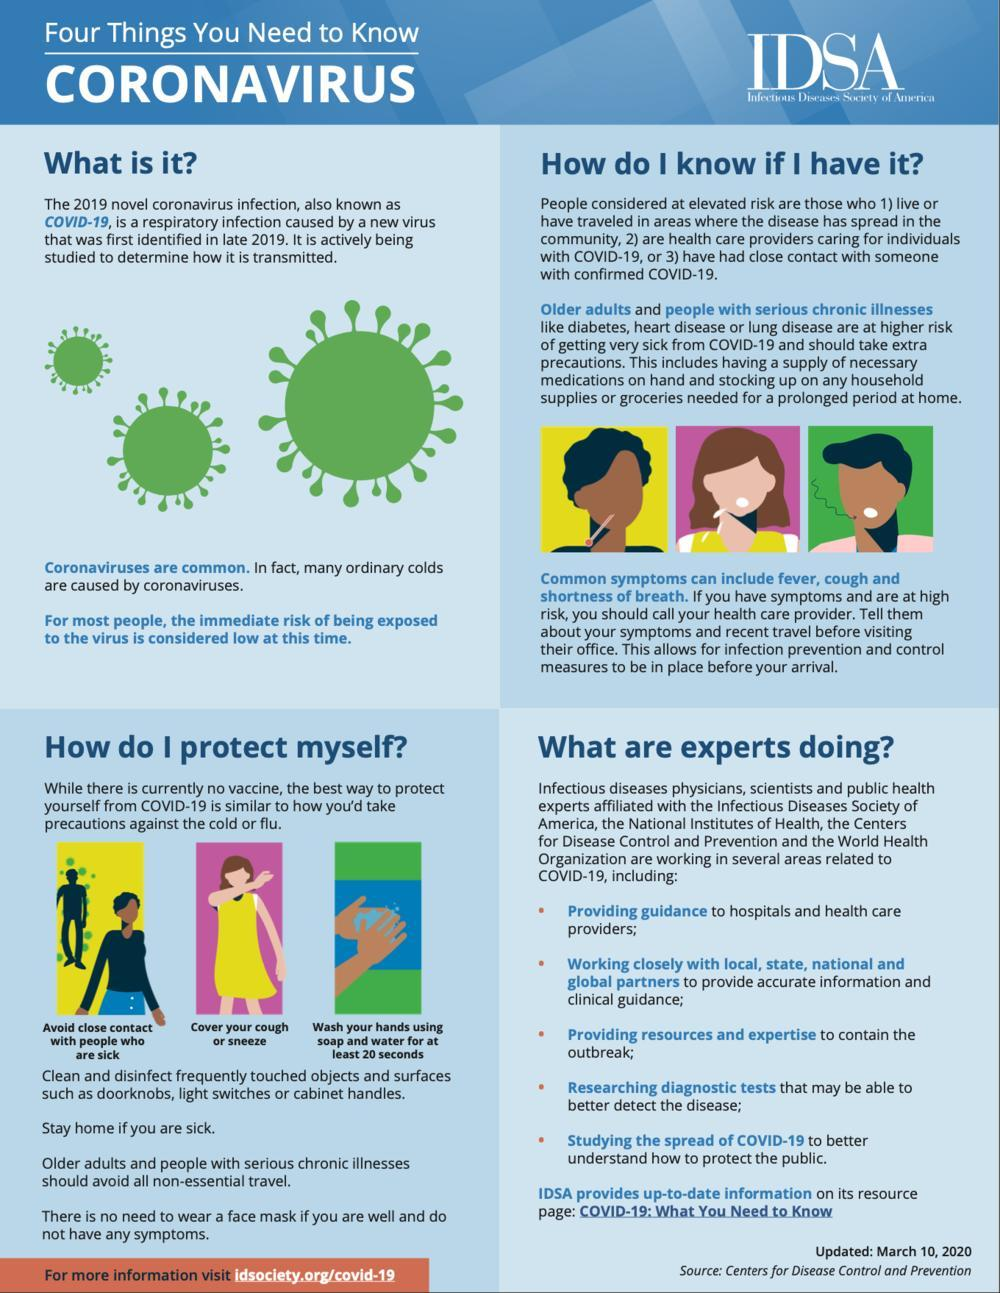What are 3 essentials that the elderly should stock at their homes?
Answer the question with a short phrase. Medications, household supplies, groceries Where should you stay if you are sick - hospital, home or grocery shop? Home What should you use to wash your hands? Soap and water How can you protect regularly touched surfaces from infection? Clean and disinfect What is the first point under 'what are experts doing'? Providing guidance to hospitals and healthcare providers; What should the elderly and the critically ill avoid doing? All non essential travel What is the minimum time specified for washing your hands? 20 seconds Which are some of the constantly touched surfaces that require cleaning? Door knobs, light switches, cabinet handles When is it safe to avoid a face mask? If you are well and do not have any symptoms What is covid-19 caused by - vaccine, virus, bacteria or fungi? Virus How many ways to protect one's self are mentioned? 7 